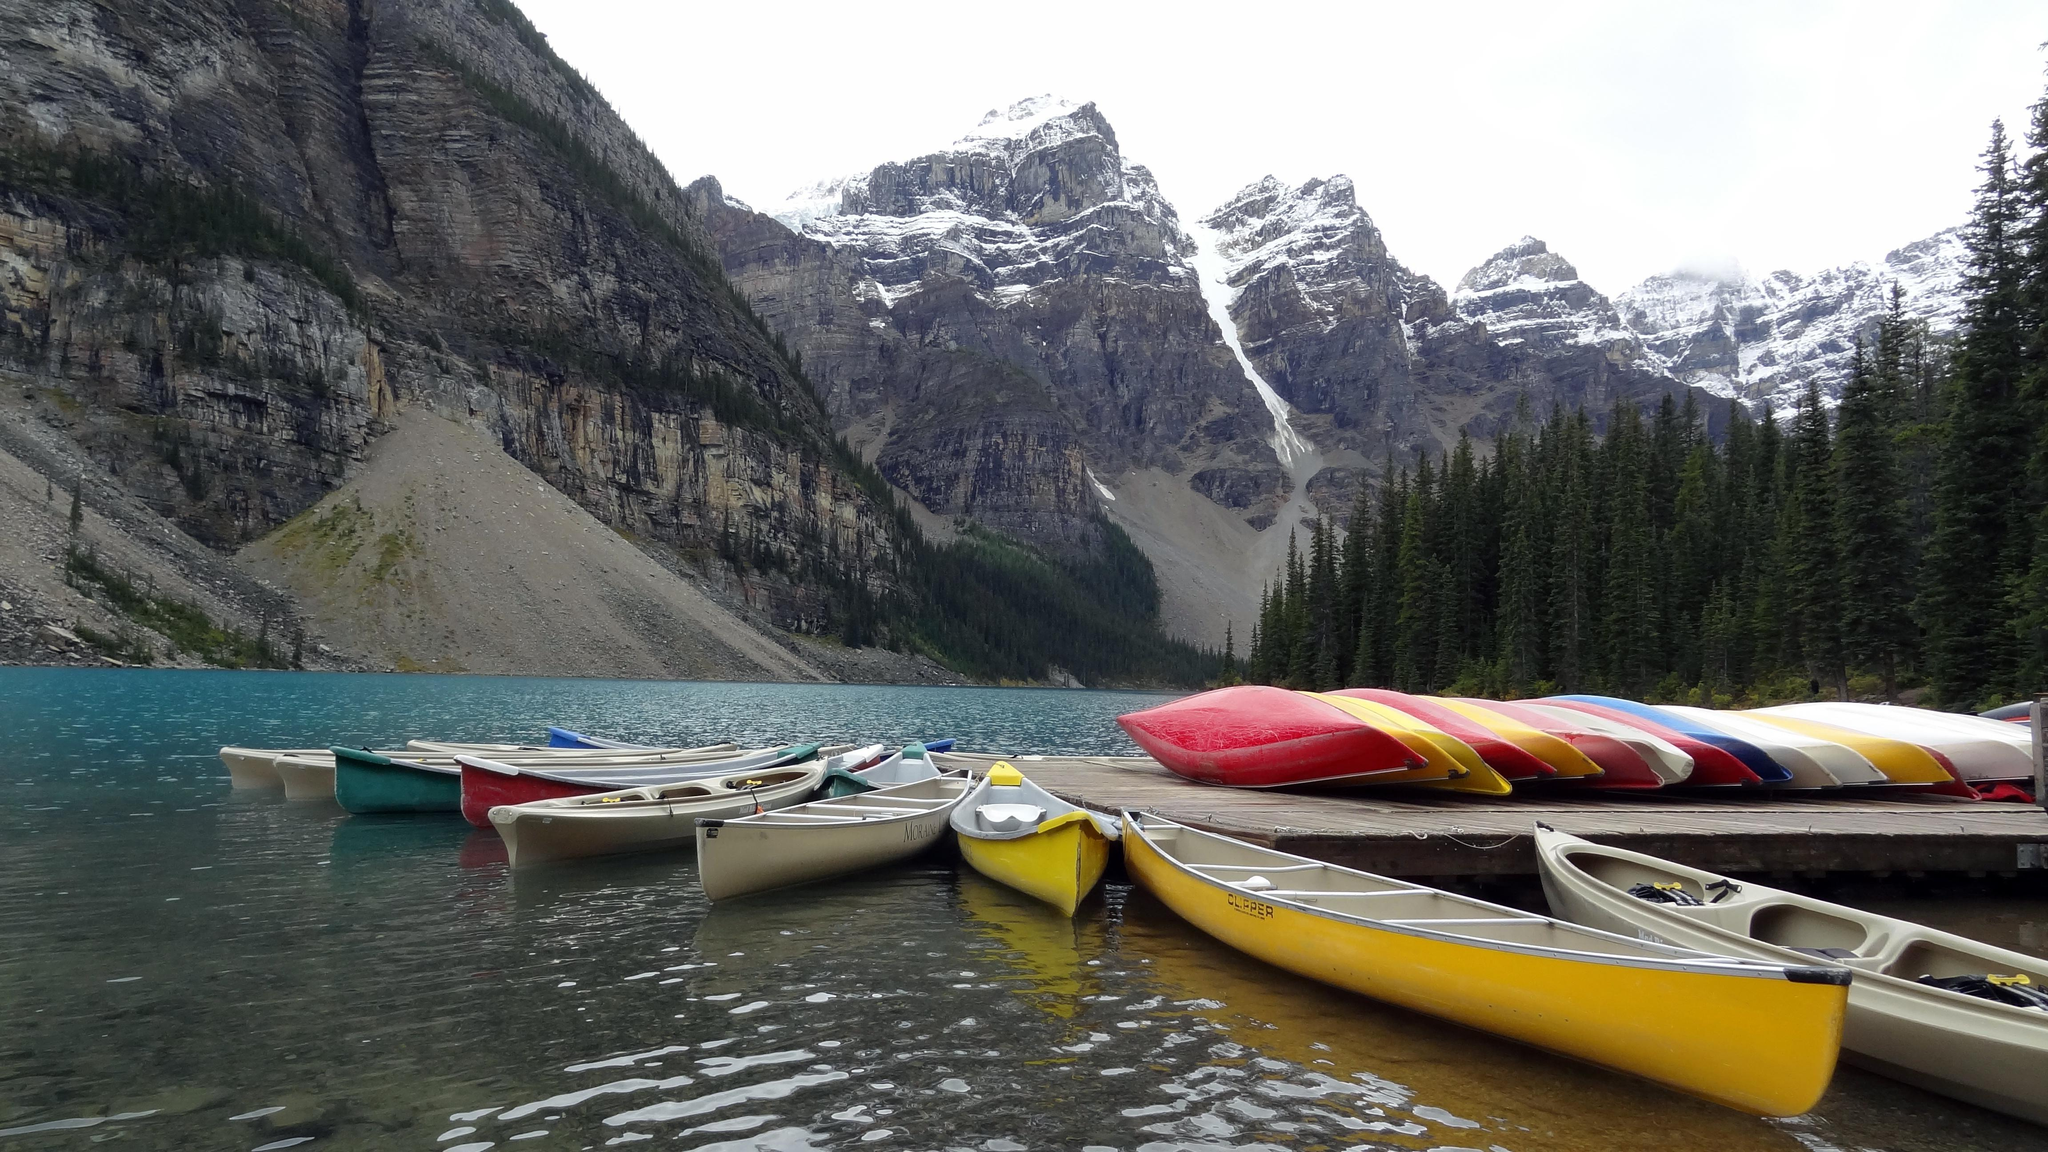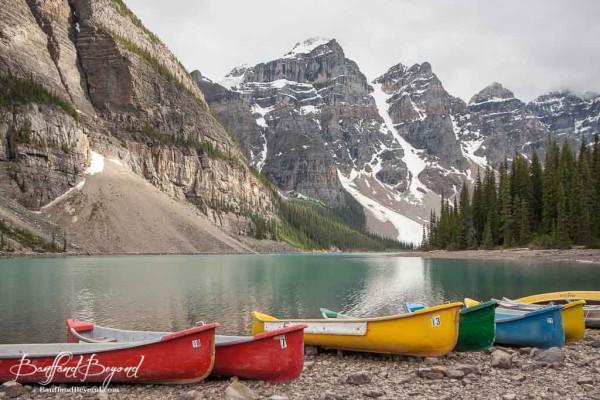The first image is the image on the left, the second image is the image on the right. For the images displayed, is the sentence "One image contains only canoes that are red." factually correct? Answer yes or no. No. 